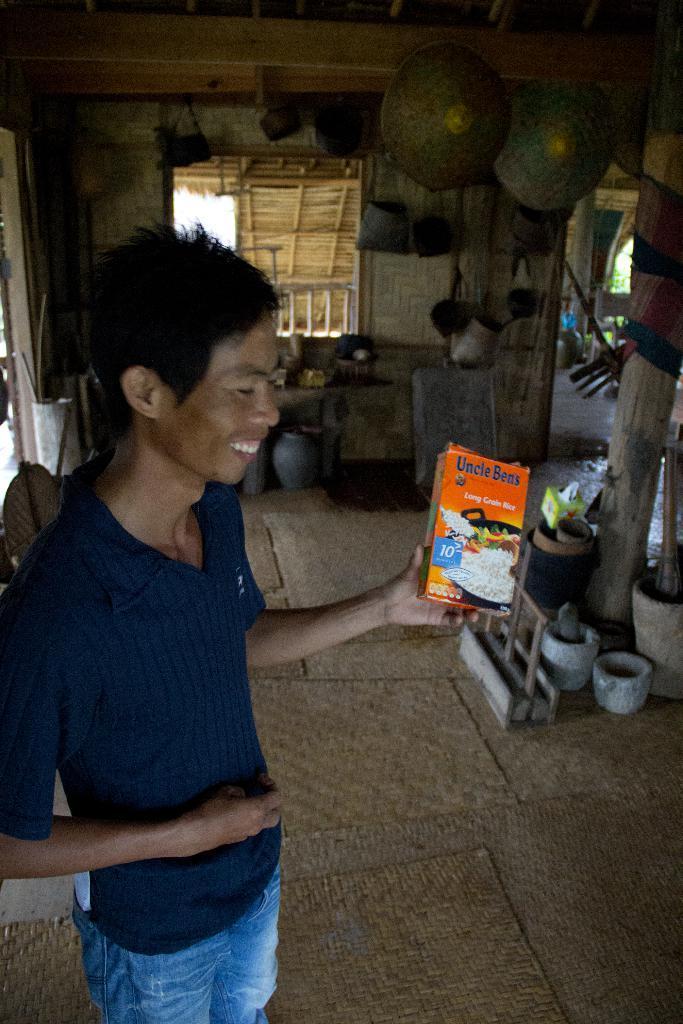Can you describe this image briefly? In this image we can see a person standing on the mat and holding box with text and image. In the background, we can see the bags, sticks, stones, boxes and a few objects. And we can see a window, through the window we can see a shed and railing. 